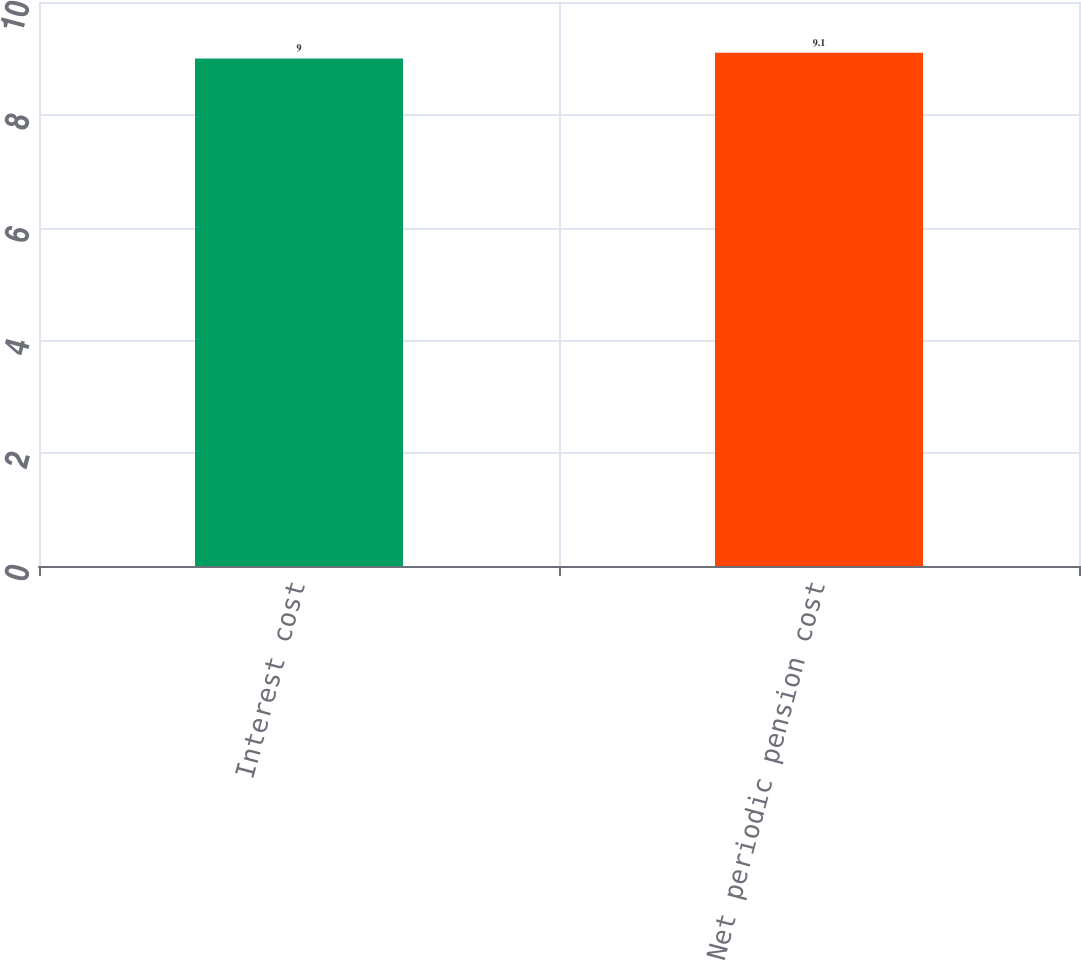Convert chart. <chart><loc_0><loc_0><loc_500><loc_500><bar_chart><fcel>Interest cost<fcel>Net periodic pension cost<nl><fcel>9<fcel>9.1<nl></chart> 